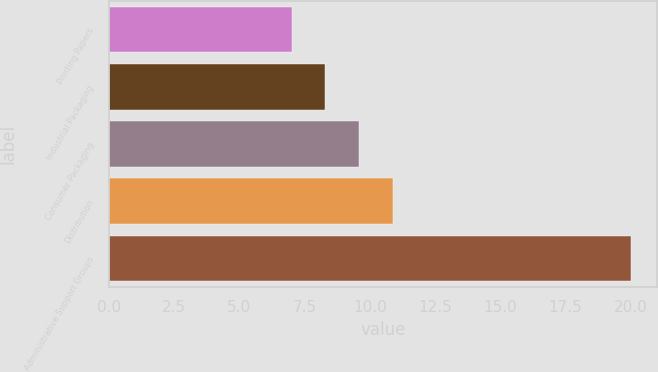<chart> <loc_0><loc_0><loc_500><loc_500><bar_chart><fcel>Printing Papers<fcel>Industrial Packaging<fcel>Consumer Packaging<fcel>Distribution<fcel>Administrative Support Groups<nl><fcel>7<fcel>8.3<fcel>9.6<fcel>10.9<fcel>20<nl></chart> 